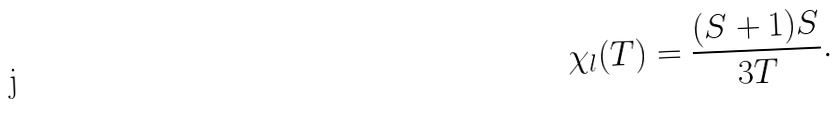<formula> <loc_0><loc_0><loc_500><loc_500>\chi _ { l } ( T ) = \frac { ( S + 1 ) S } { 3 T } .</formula> 